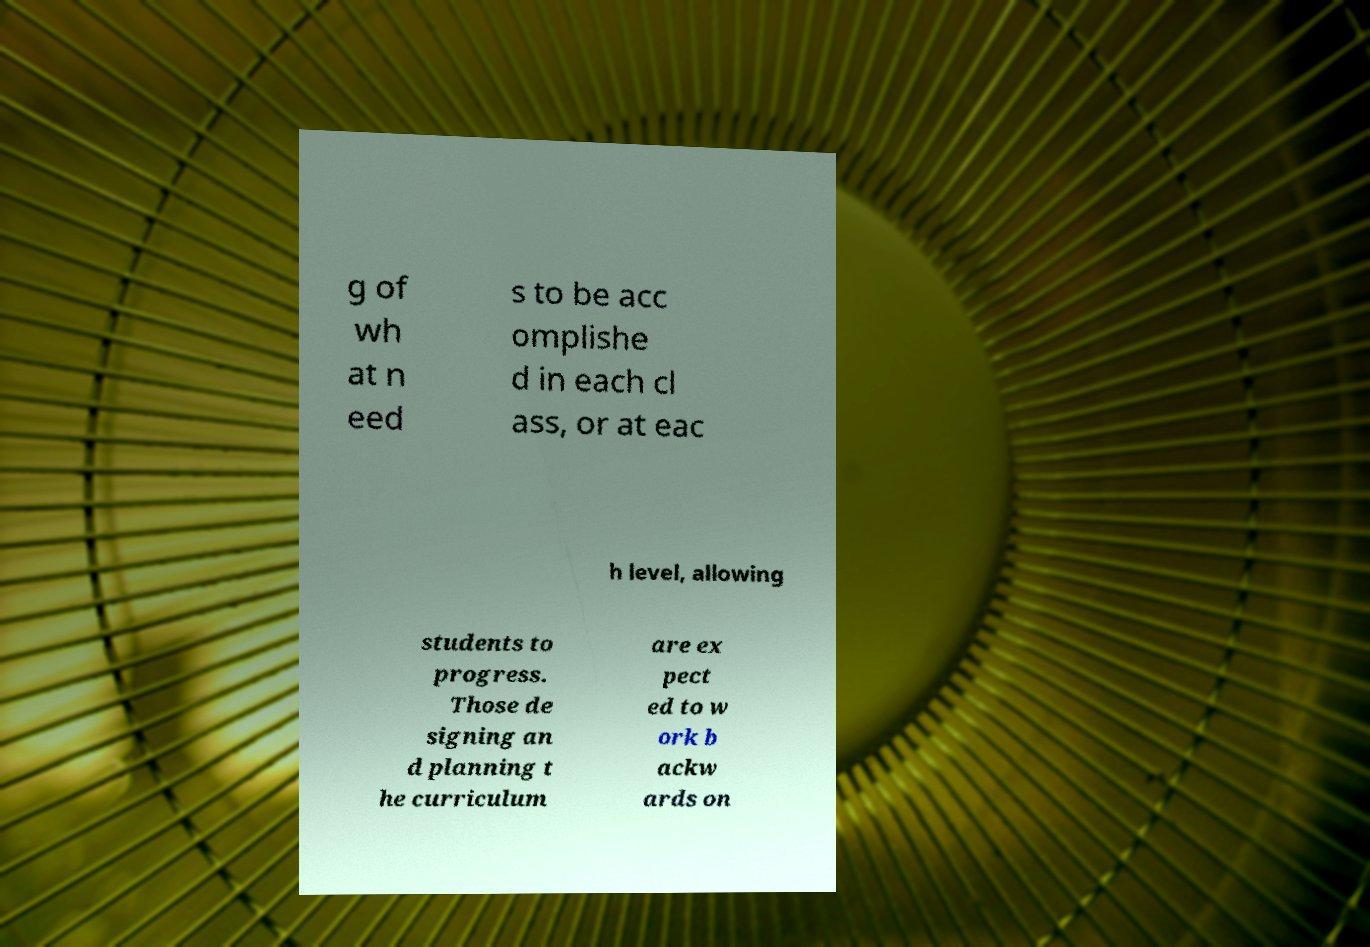Could you extract and type out the text from this image? g of wh at n eed s to be acc omplishe d in each cl ass, or at eac h level, allowing students to progress. Those de signing an d planning t he curriculum are ex pect ed to w ork b ackw ards on 